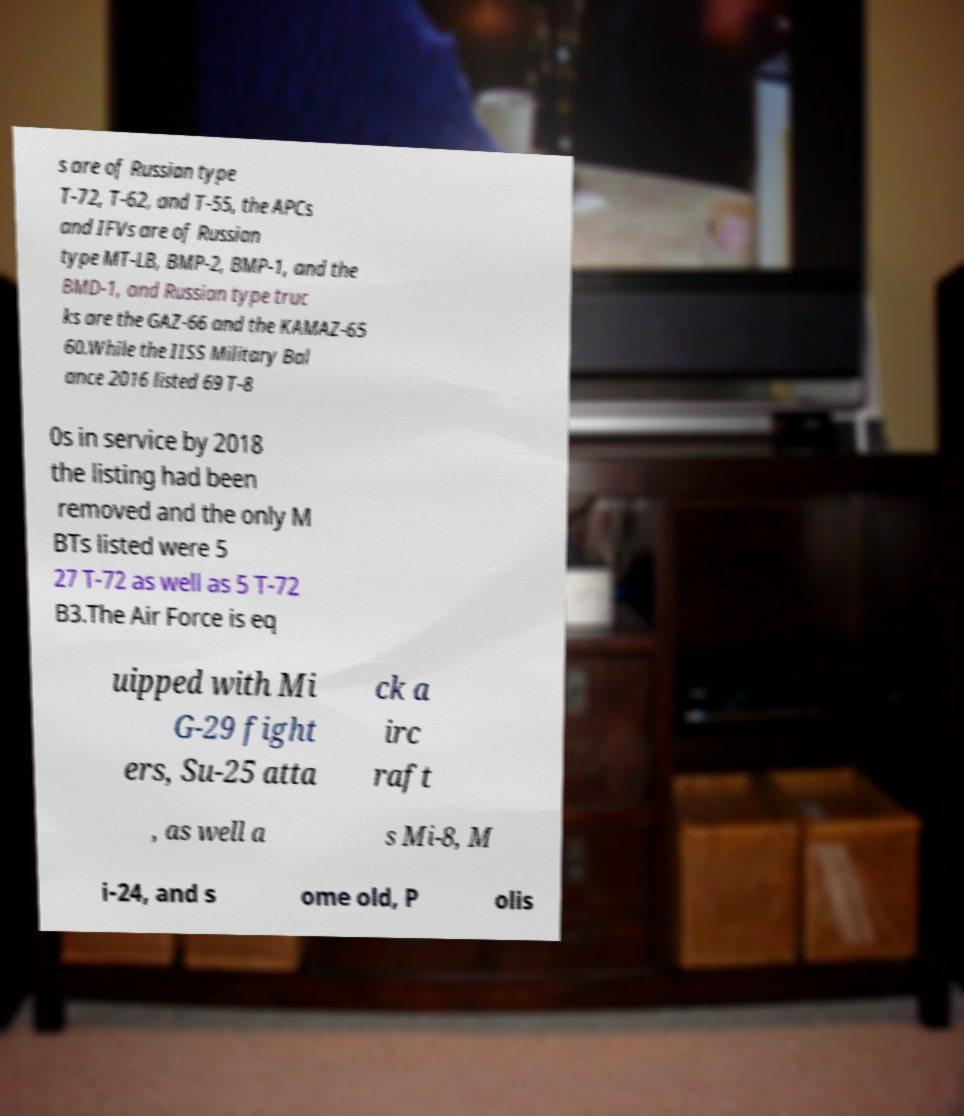What messages or text are displayed in this image? I need them in a readable, typed format. s are of Russian type T-72, T-62, and T-55, the APCs and IFVs are of Russian type MT-LB, BMP-2, BMP-1, and the BMD-1, and Russian type truc ks are the GAZ-66 and the KAMAZ-65 60.While the IISS Military Bal ance 2016 listed 69 T-8 0s in service by 2018 the listing had been removed and the only M BTs listed were 5 27 T-72 as well as 5 T-72 B3.The Air Force is eq uipped with Mi G-29 fight ers, Su-25 atta ck a irc raft , as well a s Mi-8, M i-24, and s ome old, P olis 